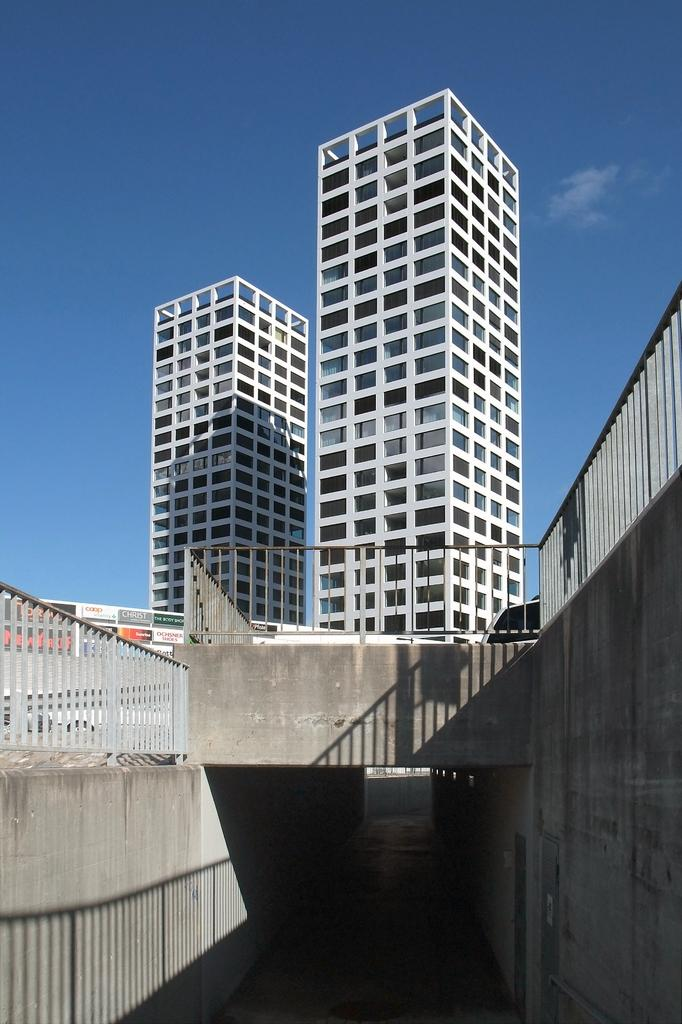What type of structure can be seen in the image? There is a tunnel in the image. What other structure is present in the image? There is a bridge with a metal rod fence in the image. How are the tunnel and bridge related in the image? The bridge is above the tunnel. What can be seen behind the fence on the bridge? There are buildings behind the fence. What is visible in the sky in the image? The sky is visible in the image, and there are clouds in the sky. What emotion is the woman expressing in the image? There is no woman present in the image, so it is not possible to determine her emotions. 